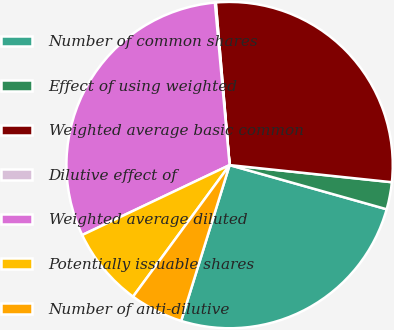Convert chart to OTSL. <chart><loc_0><loc_0><loc_500><loc_500><pie_chart><fcel>Number of common shares<fcel>Effect of using weighted<fcel>Weighted average basic common<fcel>Dilutive effect of<fcel>Weighted average diluted<fcel>Potentially issuable shares<fcel>Number of anti-dilutive<nl><fcel>25.43%<fcel>2.69%<fcel>28.02%<fcel>0.09%<fcel>30.61%<fcel>7.87%<fcel>5.28%<nl></chart> 